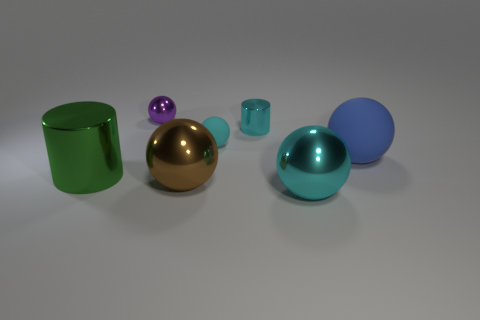What number of other objects are the same color as the small cylinder?
Your response must be concise. 2. There is a ball that is the same color as the tiny rubber object; what is its material?
Offer a very short reply. Metal. There is another tiny object that is the same shape as the green metal object; what material is it?
Your answer should be compact. Metal. Are there any other things that have the same size as the purple ball?
Offer a very short reply. Yes. Is the shape of the cyan object that is in front of the green shiny thing the same as the tiny cyan object that is on the left side of the small cylinder?
Keep it short and to the point. Yes. Is the number of small metallic cylinders that are on the right side of the brown metal thing less than the number of large cyan metallic spheres that are behind the large cyan metallic ball?
Keep it short and to the point. No. What number of other objects are there of the same shape as the small matte object?
Your answer should be compact. 4. There is another object that is the same material as the blue thing; what is its shape?
Provide a succinct answer. Sphere. What is the color of the metal thing that is behind the large green object and to the right of the small purple sphere?
Ensure brevity in your answer.  Cyan. Does the large ball to the right of the cyan metal sphere have the same material as the large green cylinder?
Ensure brevity in your answer.  No. 